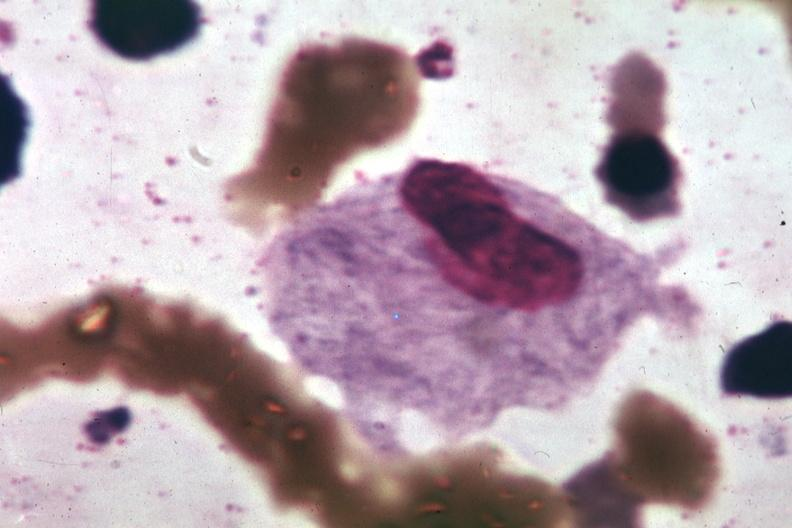s eye present?
Answer the question using a single word or phrase. No 